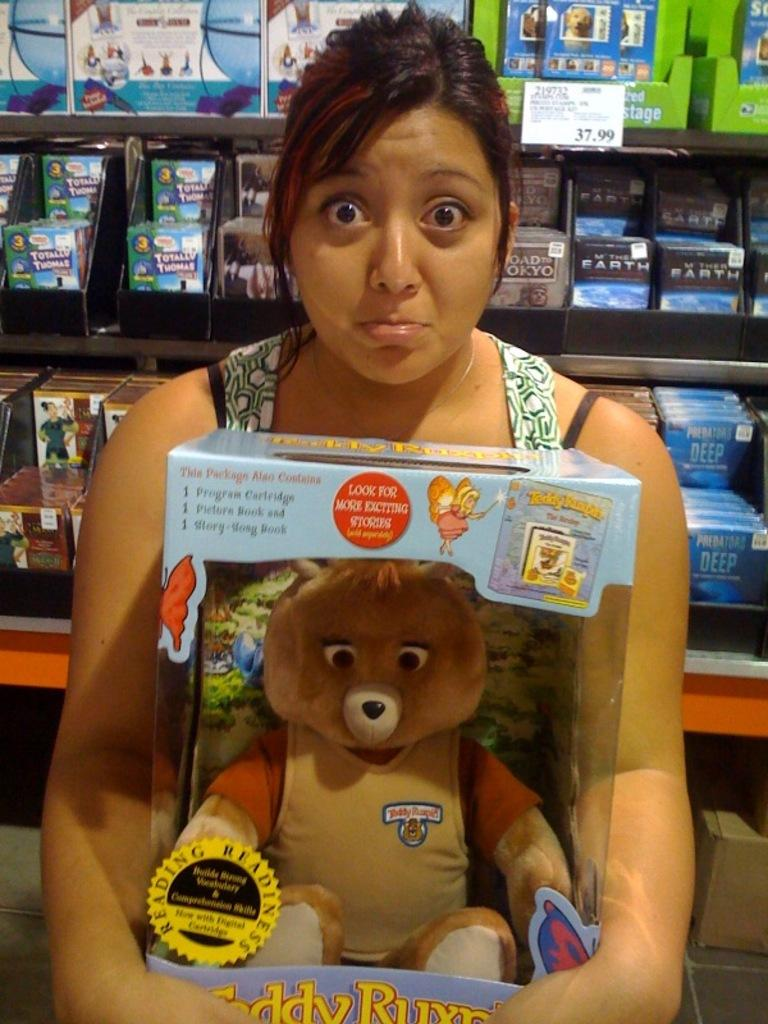Who is present in the image? There is a woman in the image. What is the woman holding in her hands? The woman is holding a toy in her hands. What can be seen in the background of the image? There are racks, boxes, and other objects in the background of the image. What type of coach is the woman using for her voyage in the image? There is no coach or voyage present in the image; it features a woman holding a toy. How much tax is the woman paying for the toy in the image? There is no indication of tax or payment in the image; it simply shows a woman holding a toy. 